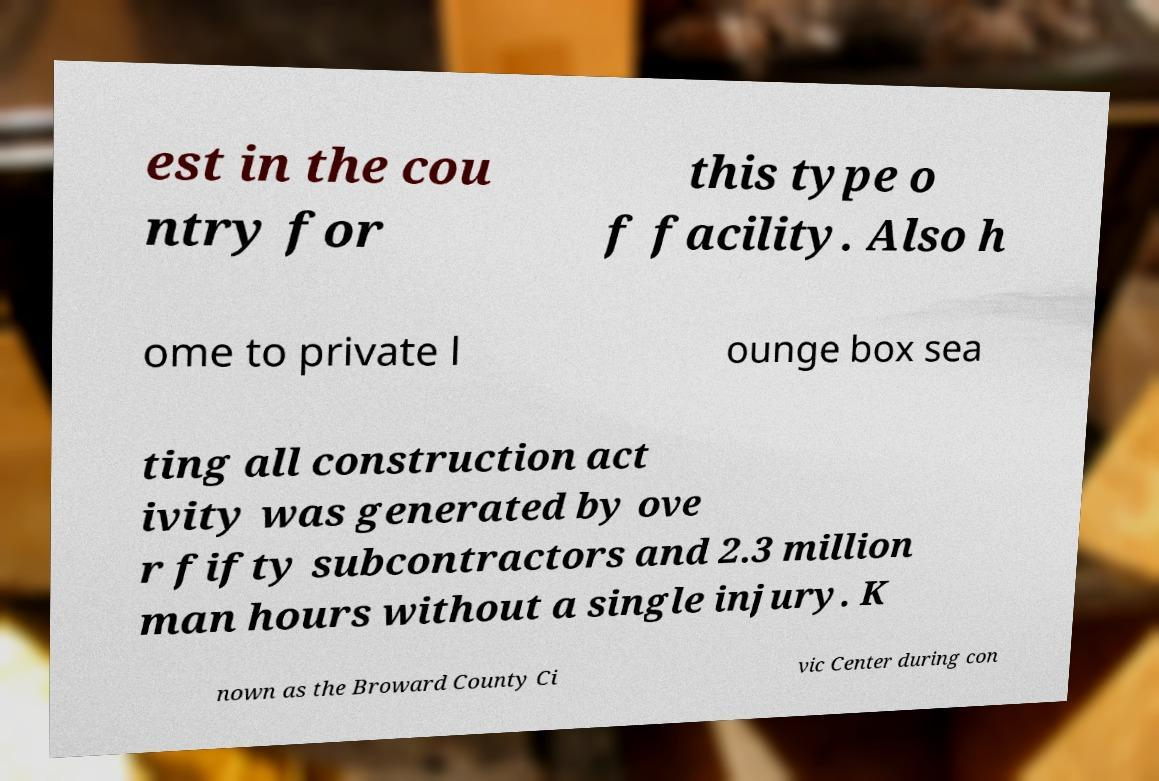Please identify and transcribe the text found in this image. est in the cou ntry for this type o f facility. Also h ome to private l ounge box sea ting all construction act ivity was generated by ove r fifty subcontractors and 2.3 million man hours without a single injury. K nown as the Broward County Ci vic Center during con 